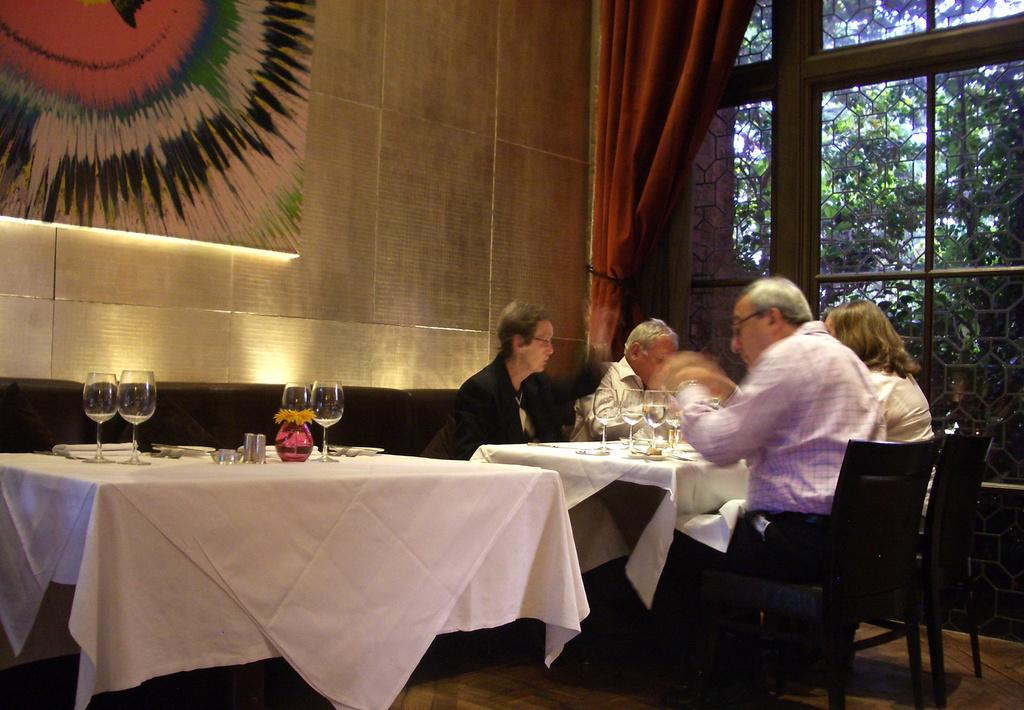What type of structure can be seen in the image? There is a wall in the image. What is located near the wall? There is a window in the image. What is associated with the window? There is a curtain associated with the window. What type of furniture is present in the image? There are tables in the image. What are the people in the image doing? There are people sitting on chairs in the image. What objects can be seen on the table? There are glasses and pillows on the table. What type of laborer is working on the basketball court in the image? There is no laborer or basketball court present in the image. 